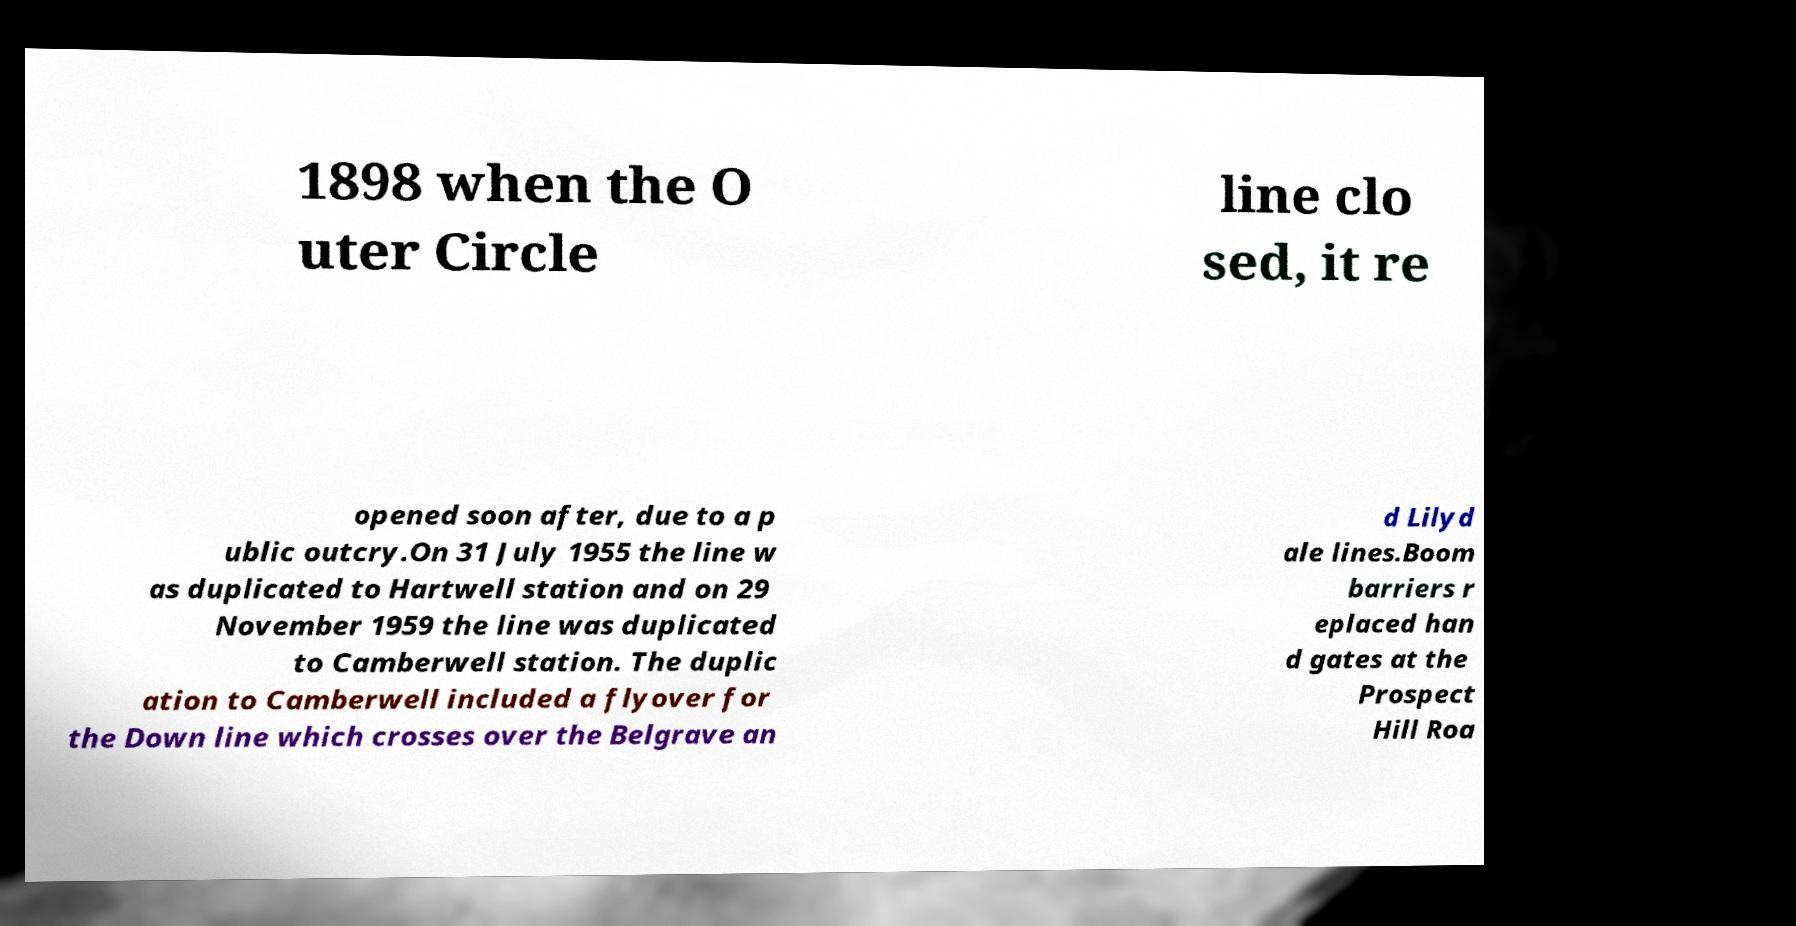Can you accurately transcribe the text from the provided image for me? 1898 when the O uter Circle line clo sed, it re opened soon after, due to a p ublic outcry.On 31 July 1955 the line w as duplicated to Hartwell station and on 29 November 1959 the line was duplicated to Camberwell station. The duplic ation to Camberwell included a flyover for the Down line which crosses over the Belgrave an d Lilyd ale lines.Boom barriers r eplaced han d gates at the Prospect Hill Roa 